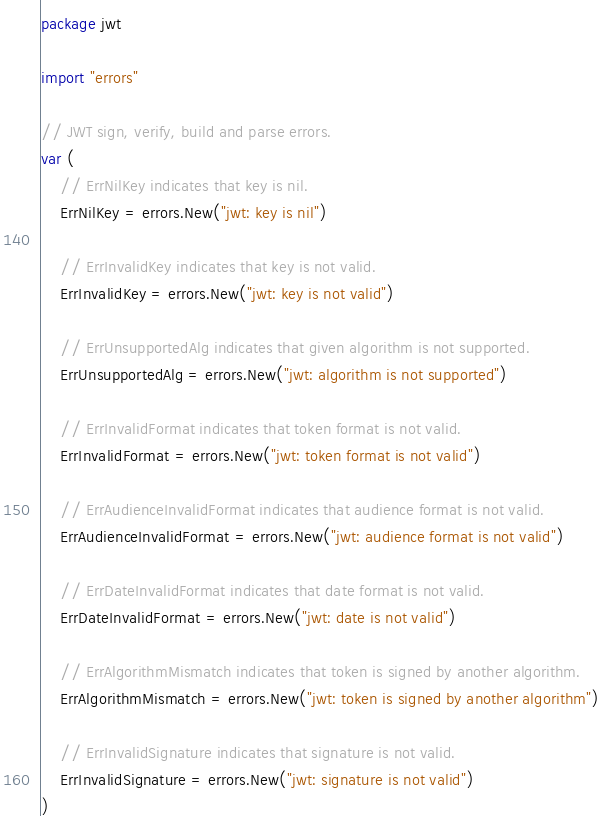<code> <loc_0><loc_0><loc_500><loc_500><_Go_>package jwt

import "errors"

// JWT sign, verify, build and parse errors.
var (
	// ErrNilKey indicates that key is nil.
	ErrNilKey = errors.New("jwt: key is nil")

	// ErrInvalidKey indicates that key is not valid.
	ErrInvalidKey = errors.New("jwt: key is not valid")

	// ErrUnsupportedAlg indicates that given algorithm is not supported.
	ErrUnsupportedAlg = errors.New("jwt: algorithm is not supported")

	// ErrInvalidFormat indicates that token format is not valid.
	ErrInvalidFormat = errors.New("jwt: token format is not valid")

	// ErrAudienceInvalidFormat indicates that audience format is not valid.
	ErrAudienceInvalidFormat = errors.New("jwt: audience format is not valid")

	// ErrDateInvalidFormat indicates that date format is not valid.
	ErrDateInvalidFormat = errors.New("jwt: date is not valid")

	// ErrAlgorithmMismatch indicates that token is signed by another algorithm.
	ErrAlgorithmMismatch = errors.New("jwt: token is signed by another algorithm")

	// ErrInvalidSignature indicates that signature is not valid.
	ErrInvalidSignature = errors.New("jwt: signature is not valid")
)
</code> 